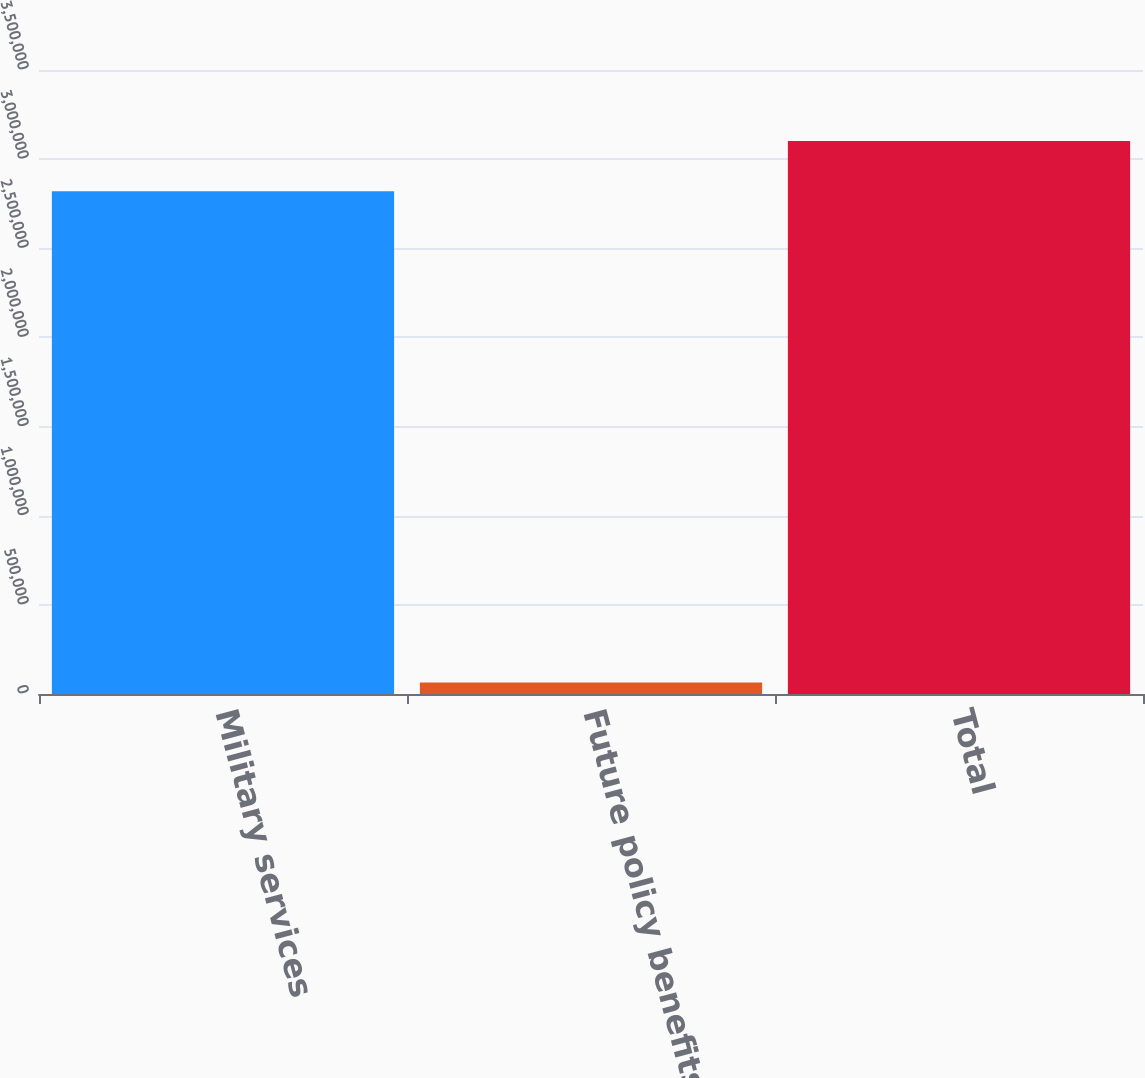<chart> <loc_0><loc_0><loc_500><loc_500><bar_chart><fcel>Military services<fcel>Future policy benefits<fcel>Total<nl><fcel>2.81979e+06<fcel>64338<fcel>3.10177e+06<nl></chart> 